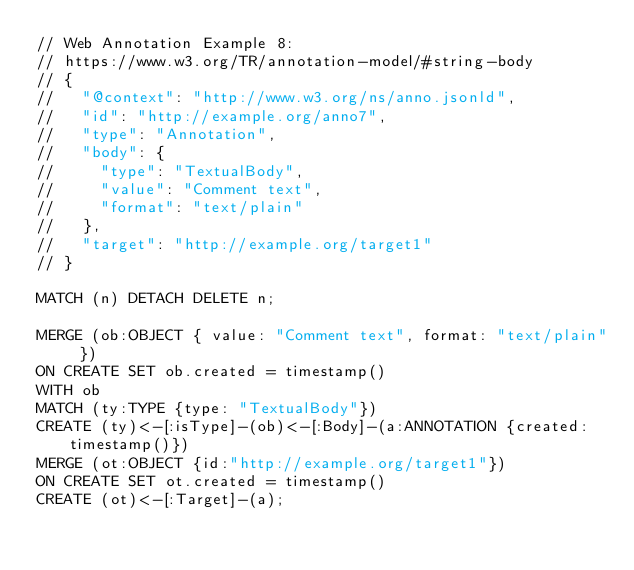Convert code to text. <code><loc_0><loc_0><loc_500><loc_500><_SQL_>// Web Annotation Example 8:
// https://www.w3.org/TR/annotation-model/#string-body
// {
//   "@context": "http://www.w3.org/ns/anno.jsonld",
//   "id": "http://example.org/anno7",
//   "type": "Annotation",
//   "body": {
//     "type": "TextualBody",
//     "value": "Comment text",
//     "format": "text/plain"
//   },
//   "target": "http://example.org/target1"
// }

MATCH (n) DETACH DELETE n;

MERGE (ob:OBJECT { value: "Comment text", format: "text/plain" })
ON CREATE SET ob.created = timestamp()
WITH ob
MATCH (ty:TYPE {type: "TextualBody"})
CREATE (ty)<-[:isType]-(ob)<-[:Body]-(a:ANNOTATION {created:timestamp()})
MERGE (ot:OBJECT {id:"http://example.org/target1"})
ON CREATE SET ot.created = timestamp()
CREATE (ot)<-[:Target]-(a);
</code> 